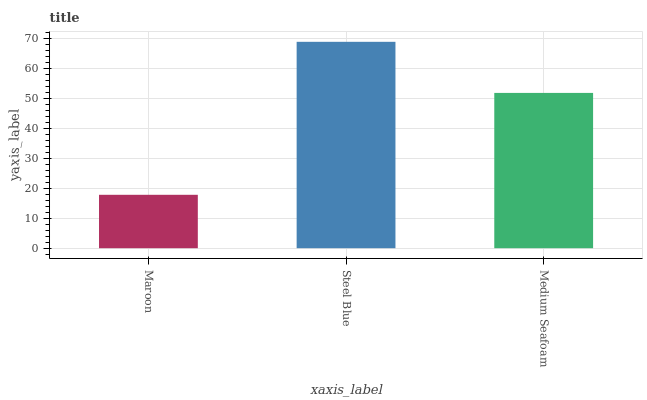Is Maroon the minimum?
Answer yes or no. Yes. Is Steel Blue the maximum?
Answer yes or no. Yes. Is Medium Seafoam the minimum?
Answer yes or no. No. Is Medium Seafoam the maximum?
Answer yes or no. No. Is Steel Blue greater than Medium Seafoam?
Answer yes or no. Yes. Is Medium Seafoam less than Steel Blue?
Answer yes or no. Yes. Is Medium Seafoam greater than Steel Blue?
Answer yes or no. No. Is Steel Blue less than Medium Seafoam?
Answer yes or no. No. Is Medium Seafoam the high median?
Answer yes or no. Yes. Is Medium Seafoam the low median?
Answer yes or no. Yes. Is Steel Blue the high median?
Answer yes or no. No. Is Maroon the low median?
Answer yes or no. No. 